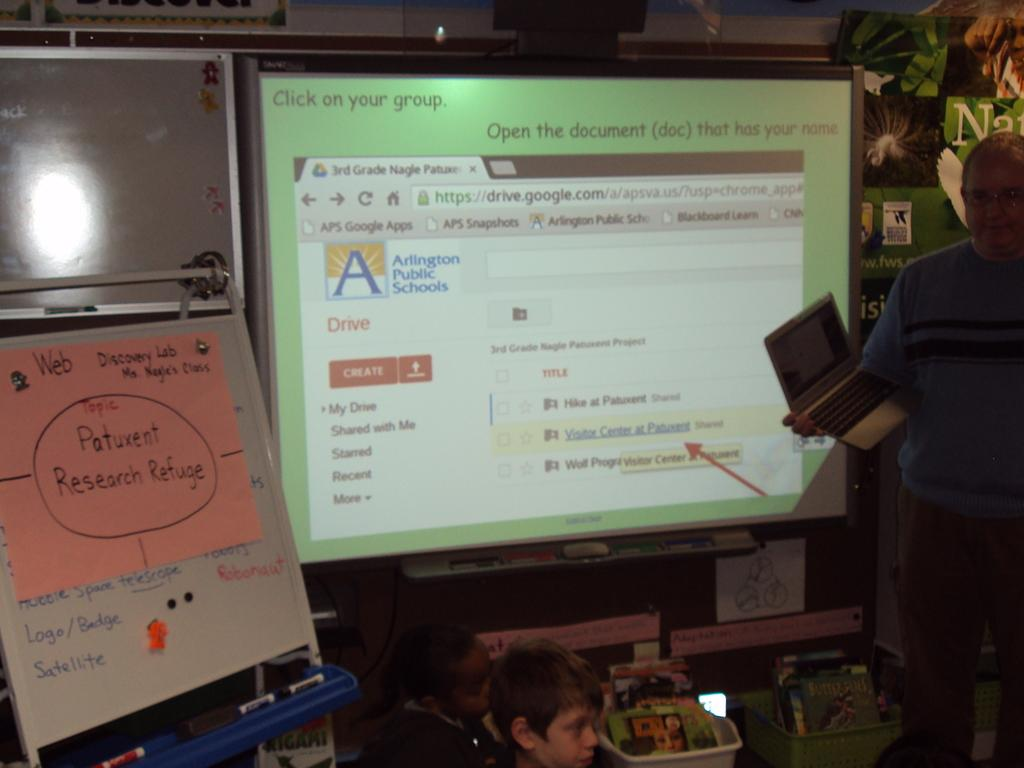<image>
Write a terse but informative summary of the picture. A computer monitior that shows a display screen that shows a webpage for Arlington Public Schools 